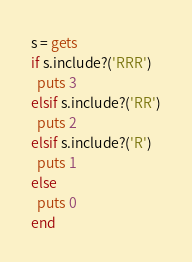Convert code to text. <code><loc_0><loc_0><loc_500><loc_500><_Ruby_>s = gets
if s.include?('RRR')
  puts 3
elsif s.include?('RR')
  puts 2
elsif s.include?('R')
  puts 1
else
  puts 0
end
</code> 